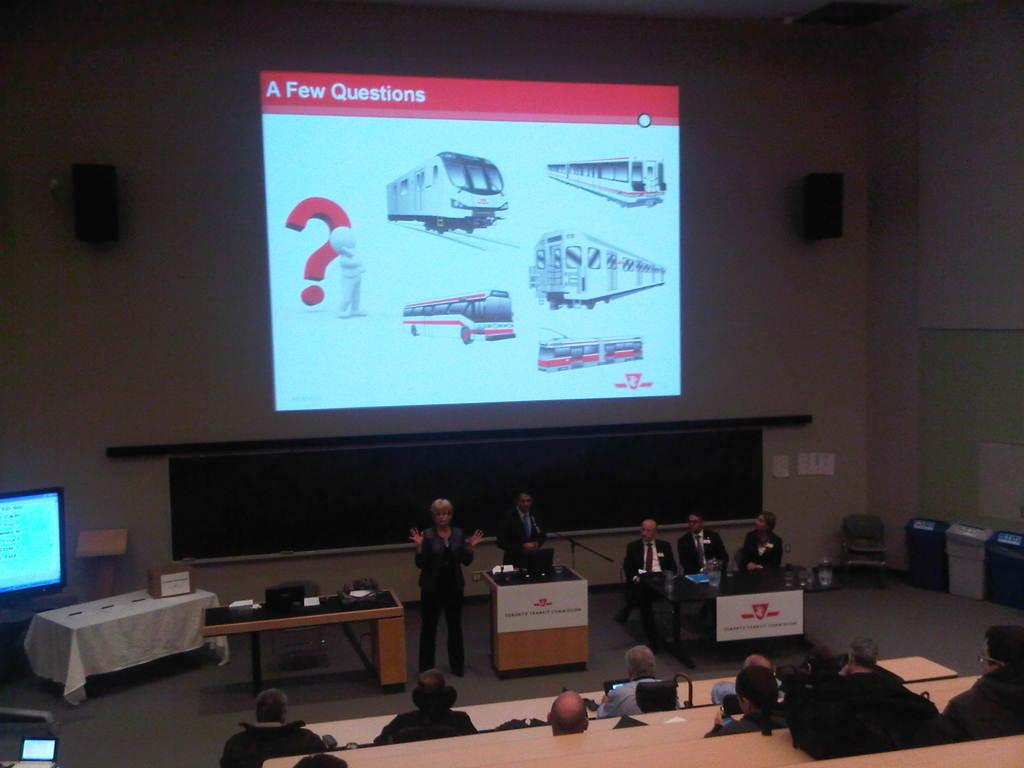<image>
Create a compact narrative representing the image presented. A lecture screen shows several pictures of trams with the words 'A Few Questions in the upper left of the screen. 